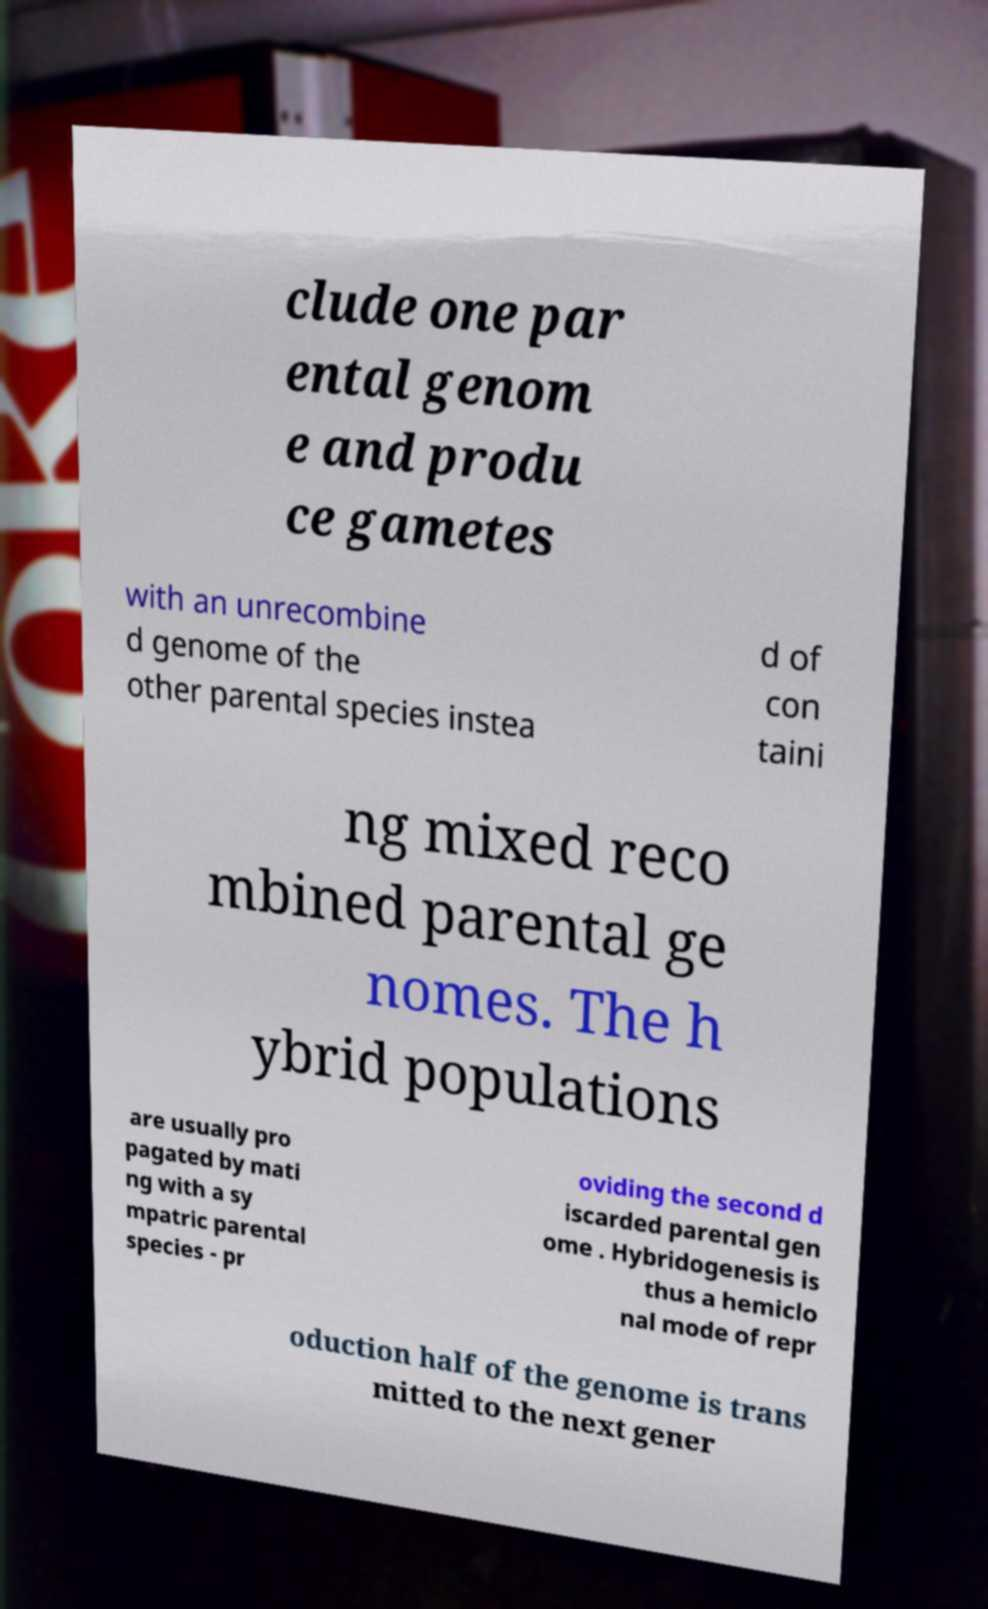Please identify and transcribe the text found in this image. clude one par ental genom e and produ ce gametes with an unrecombine d genome of the other parental species instea d of con taini ng mixed reco mbined parental ge nomes. The h ybrid populations are usually pro pagated by mati ng with a sy mpatric parental species - pr oviding the second d iscarded parental gen ome . Hybridogenesis is thus a hemiclo nal mode of repr oduction half of the genome is trans mitted to the next gener 